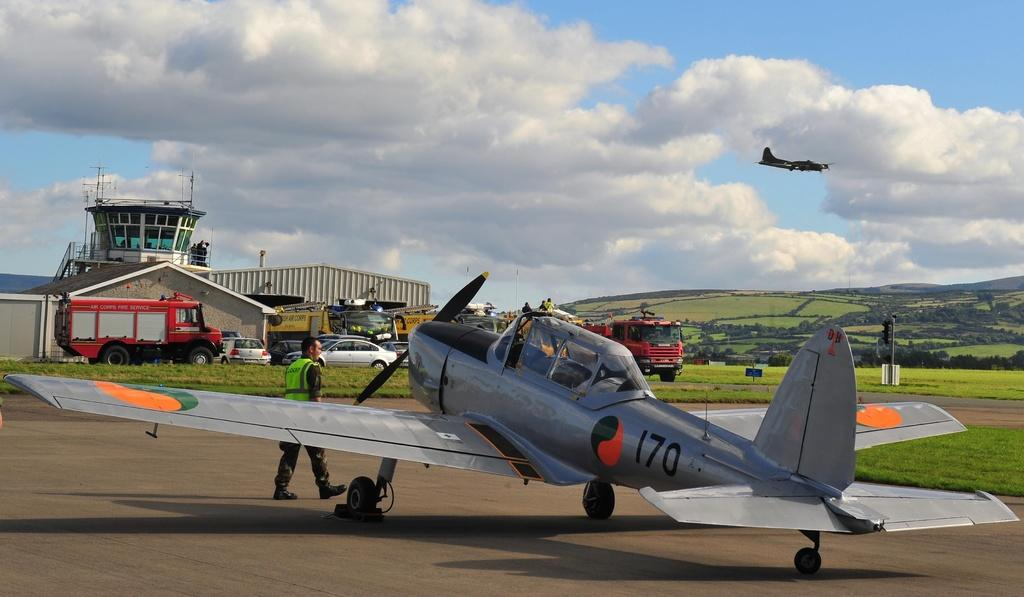Provide a one-sentence caption for the provided image. Plane number 170 getting ready for takeoff into the sky,. 